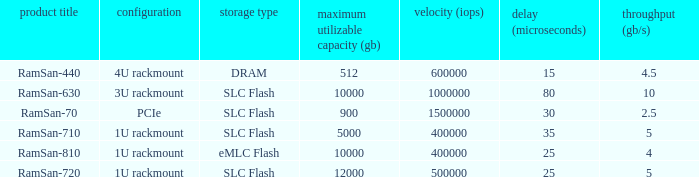List the number of ramsan-720 hard drives? 1.0. 